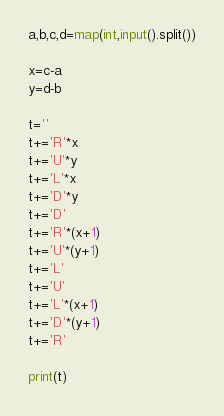<code> <loc_0><loc_0><loc_500><loc_500><_Python_>a,b,c,d=map(int,input().split())

x=c-a
y=d-b

t=''
t+='R'*x
t+='U'*y
t+='L'*x
t+='D'*y
t+='D'
t+='R'*(x+1)
t+='U'*(y+1)
t+='L'
t+='U'
t+='L'*(x+1)
t+='D'*(y+1)
t+='R'

print(t)</code> 